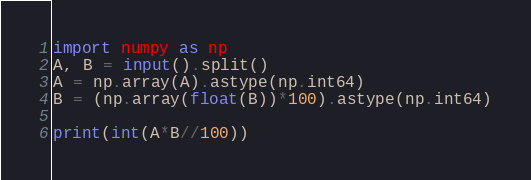<code> <loc_0><loc_0><loc_500><loc_500><_Python_>import numpy as np
A, B = input().split()
A = np.array(A).astype(np.int64)
B = (np.array(float(B))*100).astype(np.int64)

print(int(A*B//100))</code> 